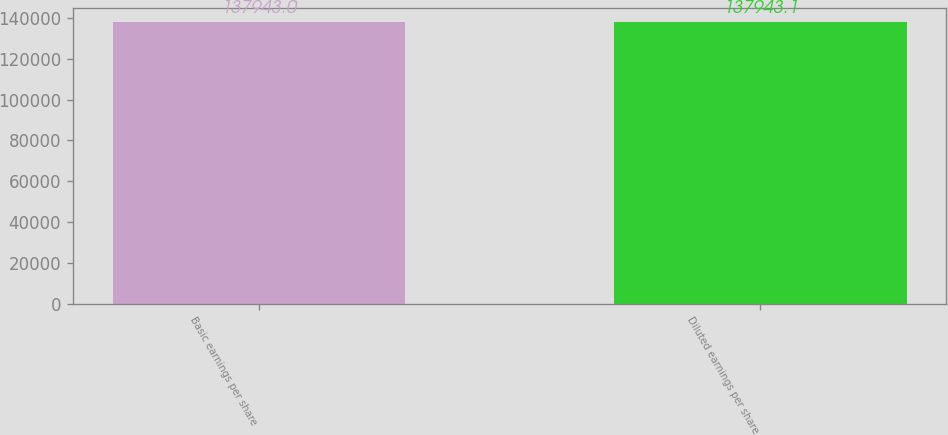<chart> <loc_0><loc_0><loc_500><loc_500><bar_chart><fcel>Basic earnings per share<fcel>Diluted earnings per share<nl><fcel>137943<fcel>137943<nl></chart> 